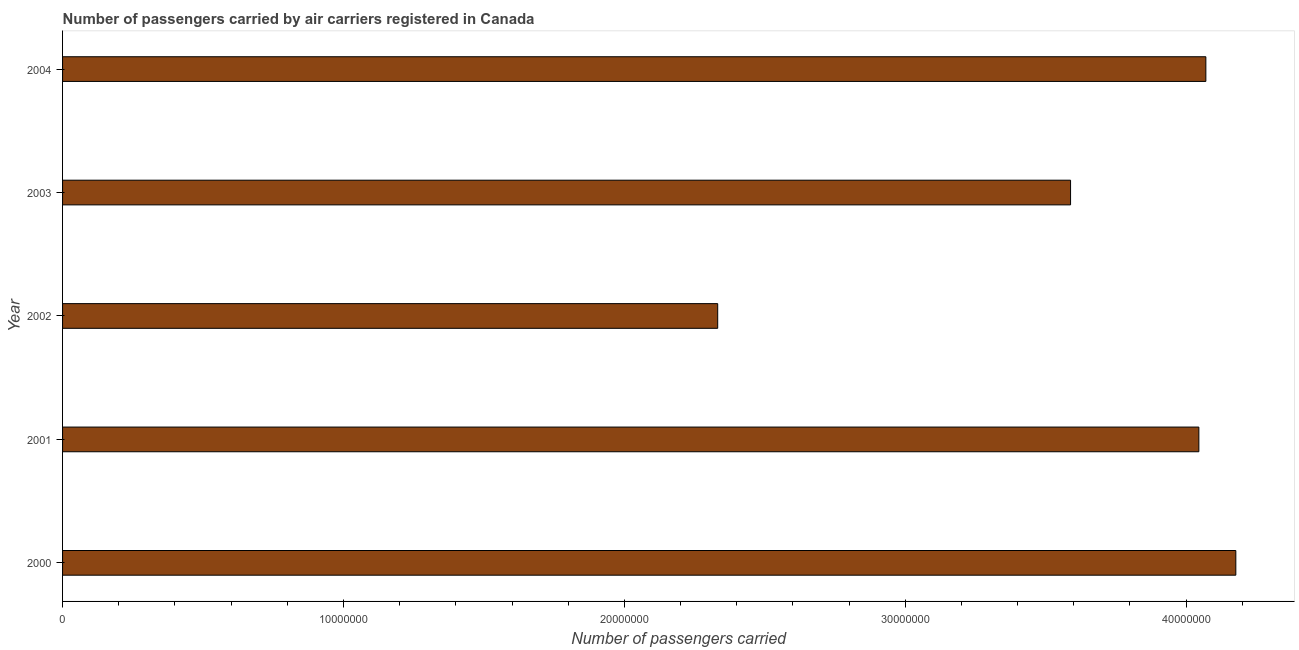Does the graph contain any zero values?
Your response must be concise. No. Does the graph contain grids?
Your answer should be compact. No. What is the title of the graph?
Offer a very short reply. Number of passengers carried by air carriers registered in Canada. What is the label or title of the X-axis?
Offer a very short reply. Number of passengers carried. What is the label or title of the Y-axis?
Provide a succinct answer. Year. What is the number of passengers carried in 2003?
Offer a terse response. 3.59e+07. Across all years, what is the maximum number of passengers carried?
Offer a very short reply. 4.18e+07. Across all years, what is the minimum number of passengers carried?
Provide a short and direct response. 2.33e+07. What is the sum of the number of passengers carried?
Provide a short and direct response. 1.82e+08. What is the difference between the number of passengers carried in 2001 and 2004?
Your answer should be compact. -2.49e+05. What is the average number of passengers carried per year?
Your answer should be compact. 3.64e+07. What is the median number of passengers carried?
Provide a short and direct response. 4.05e+07. Do a majority of the years between 2002 and 2003 (inclusive) have number of passengers carried greater than 10000000 ?
Your answer should be compact. Yes. What is the ratio of the number of passengers carried in 2001 to that in 2003?
Make the answer very short. 1.13. Is the difference between the number of passengers carried in 2002 and 2003 greater than the difference between any two years?
Your answer should be very brief. No. What is the difference between the highest and the second highest number of passengers carried?
Keep it short and to the point. 1.07e+06. What is the difference between the highest and the lowest number of passengers carried?
Provide a succinct answer. 1.84e+07. How many bars are there?
Keep it short and to the point. 5. What is the Number of passengers carried of 2000?
Ensure brevity in your answer.  4.18e+07. What is the Number of passengers carried of 2001?
Provide a succinct answer. 4.05e+07. What is the Number of passengers carried of 2002?
Your answer should be very brief. 2.33e+07. What is the Number of passengers carried in 2003?
Make the answer very short. 3.59e+07. What is the Number of passengers carried of 2004?
Keep it short and to the point. 4.07e+07. What is the difference between the Number of passengers carried in 2000 and 2001?
Offer a very short reply. 1.32e+06. What is the difference between the Number of passengers carried in 2000 and 2002?
Offer a very short reply. 1.84e+07. What is the difference between the Number of passengers carried in 2000 and 2003?
Your response must be concise. 5.88e+06. What is the difference between the Number of passengers carried in 2000 and 2004?
Your response must be concise. 1.07e+06. What is the difference between the Number of passengers carried in 2001 and 2002?
Provide a short and direct response. 1.71e+07. What is the difference between the Number of passengers carried in 2001 and 2003?
Provide a short and direct response. 4.57e+06. What is the difference between the Number of passengers carried in 2001 and 2004?
Give a very brief answer. -2.49e+05. What is the difference between the Number of passengers carried in 2002 and 2003?
Provide a short and direct response. -1.26e+07. What is the difference between the Number of passengers carried in 2002 and 2004?
Your answer should be compact. -1.74e+07. What is the difference between the Number of passengers carried in 2003 and 2004?
Provide a short and direct response. -4.82e+06. What is the ratio of the Number of passengers carried in 2000 to that in 2001?
Ensure brevity in your answer.  1.03. What is the ratio of the Number of passengers carried in 2000 to that in 2002?
Give a very brief answer. 1.79. What is the ratio of the Number of passengers carried in 2000 to that in 2003?
Offer a very short reply. 1.16. What is the ratio of the Number of passengers carried in 2001 to that in 2002?
Keep it short and to the point. 1.73. What is the ratio of the Number of passengers carried in 2001 to that in 2003?
Provide a short and direct response. 1.13. What is the ratio of the Number of passengers carried in 2001 to that in 2004?
Your answer should be compact. 0.99. What is the ratio of the Number of passengers carried in 2002 to that in 2003?
Your response must be concise. 0.65. What is the ratio of the Number of passengers carried in 2002 to that in 2004?
Your response must be concise. 0.57. What is the ratio of the Number of passengers carried in 2003 to that in 2004?
Give a very brief answer. 0.88. 